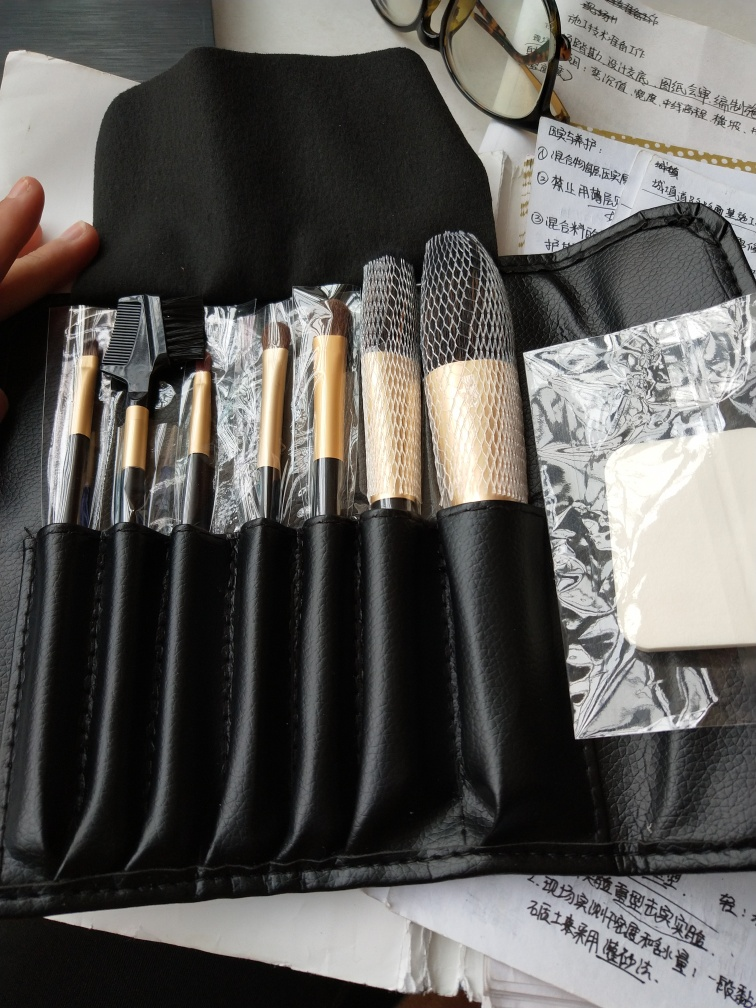What is the quality of this image?
A. Poor
B. Bad
C. Good
Answer with the option's letter from the given choices directly. The image appears to have a good resolution and the details within the frame, such as makeup brushes, a spectacle case, and papers with text, are clear and well-defined. The lighting is balanced, ensuring that colors and textures are visible without harsh shadows or overexposures. Therefore, the quality of the image can be considered good. 